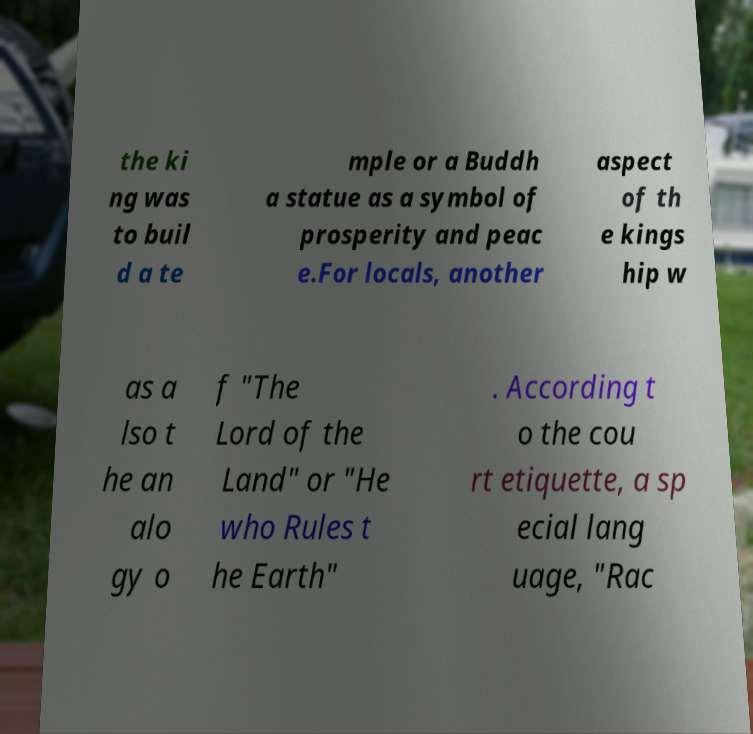Please identify and transcribe the text found in this image. the ki ng was to buil d a te mple or a Buddh a statue as a symbol of prosperity and peac e.For locals, another aspect of th e kings hip w as a lso t he an alo gy o f "The Lord of the Land" or "He who Rules t he Earth" . According t o the cou rt etiquette, a sp ecial lang uage, "Rac 